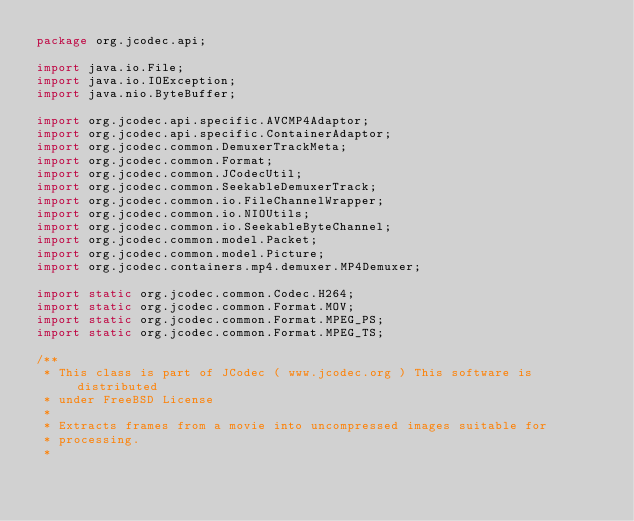<code> <loc_0><loc_0><loc_500><loc_500><_Java_>package org.jcodec.api;

import java.io.File;
import java.io.IOException;
import java.nio.ByteBuffer;

import org.jcodec.api.specific.AVCMP4Adaptor;
import org.jcodec.api.specific.ContainerAdaptor;
import org.jcodec.common.DemuxerTrackMeta;
import org.jcodec.common.Format;
import org.jcodec.common.JCodecUtil;
import org.jcodec.common.SeekableDemuxerTrack;
import org.jcodec.common.io.FileChannelWrapper;
import org.jcodec.common.io.NIOUtils;
import org.jcodec.common.io.SeekableByteChannel;
import org.jcodec.common.model.Packet;
import org.jcodec.common.model.Picture;
import org.jcodec.containers.mp4.demuxer.MP4Demuxer;

import static org.jcodec.common.Codec.H264;
import static org.jcodec.common.Format.MOV;
import static org.jcodec.common.Format.MPEG_PS;
import static org.jcodec.common.Format.MPEG_TS;

/**
 * This class is part of JCodec ( www.jcodec.org ) This software is distributed
 * under FreeBSD License
 * 
 * Extracts frames from a movie into uncompressed images suitable for
 * processing.
 * </code> 